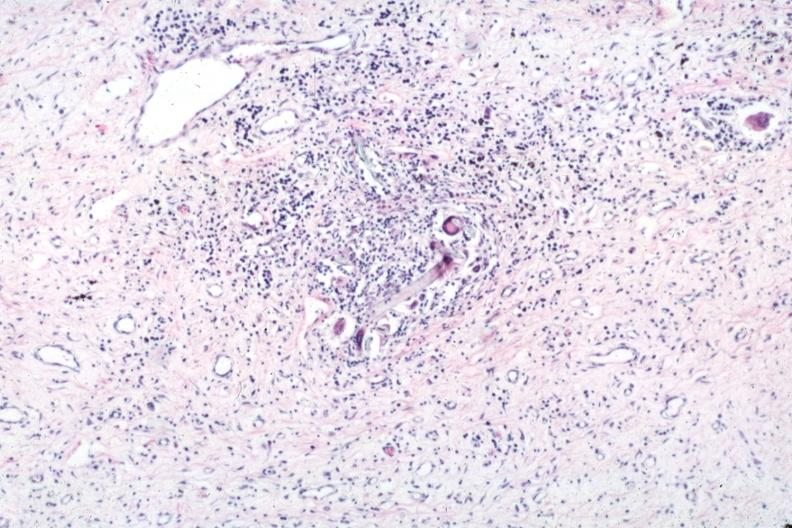where is this?
Answer the question using a single word or phrase. Skin 